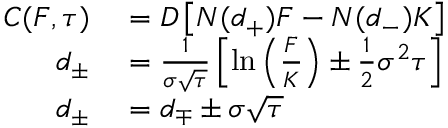Convert formula to latex. <formula><loc_0><loc_0><loc_500><loc_500>\begin{array} { r l } { C ( F , \tau ) } & = D \left [ N ( d _ { + } ) F - N ( d _ { - } ) K \right ] } \\ { d _ { \pm } } & = { \frac { 1 } { \sigma { \sqrt { \tau } } } } \left [ \ln \left ( { \frac { F } { K } } \right ) \pm { \frac { 1 } { 2 } } \sigma ^ { 2 } \tau \right ] } \\ { d _ { \pm } } & = d _ { \mp } \pm \sigma { \sqrt { \tau } } } \end{array}</formula> 